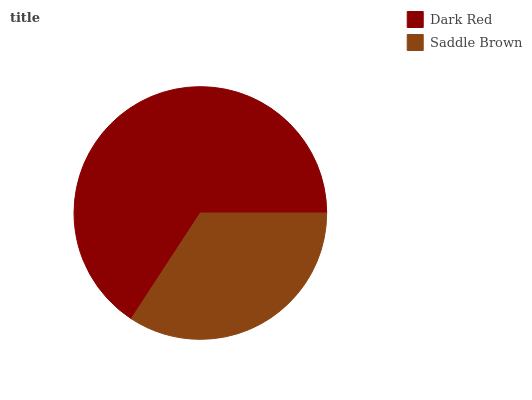Is Saddle Brown the minimum?
Answer yes or no. Yes. Is Dark Red the maximum?
Answer yes or no. Yes. Is Saddle Brown the maximum?
Answer yes or no. No. Is Dark Red greater than Saddle Brown?
Answer yes or no. Yes. Is Saddle Brown less than Dark Red?
Answer yes or no. Yes. Is Saddle Brown greater than Dark Red?
Answer yes or no. No. Is Dark Red less than Saddle Brown?
Answer yes or no. No. Is Dark Red the high median?
Answer yes or no. Yes. Is Saddle Brown the low median?
Answer yes or no. Yes. Is Saddle Brown the high median?
Answer yes or no. No. Is Dark Red the low median?
Answer yes or no. No. 